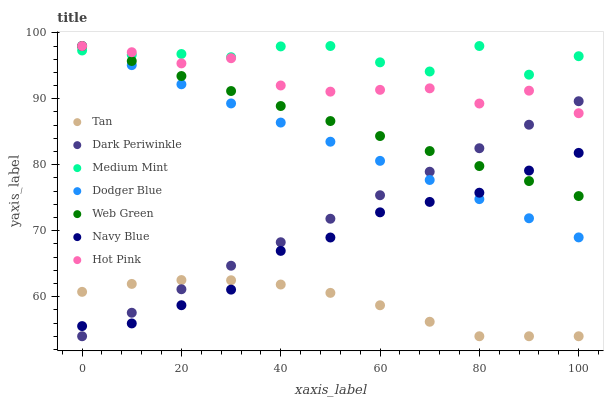Does Tan have the minimum area under the curve?
Answer yes or no. Yes. Does Medium Mint have the maximum area under the curve?
Answer yes or no. Yes. Does Navy Blue have the minimum area under the curve?
Answer yes or no. No. Does Navy Blue have the maximum area under the curve?
Answer yes or no. No. Is Dodger Blue the smoothest?
Answer yes or no. Yes. Is Medium Mint the roughest?
Answer yes or no. Yes. Is Navy Blue the smoothest?
Answer yes or no. No. Is Navy Blue the roughest?
Answer yes or no. No. Does Tan have the lowest value?
Answer yes or no. Yes. Does Navy Blue have the lowest value?
Answer yes or no. No. Does Dodger Blue have the highest value?
Answer yes or no. Yes. Does Navy Blue have the highest value?
Answer yes or no. No. Is Navy Blue less than Medium Mint?
Answer yes or no. Yes. Is Medium Mint greater than Dark Periwinkle?
Answer yes or no. Yes. Does Web Green intersect Dark Periwinkle?
Answer yes or no. Yes. Is Web Green less than Dark Periwinkle?
Answer yes or no. No. Is Web Green greater than Dark Periwinkle?
Answer yes or no. No. Does Navy Blue intersect Medium Mint?
Answer yes or no. No. 